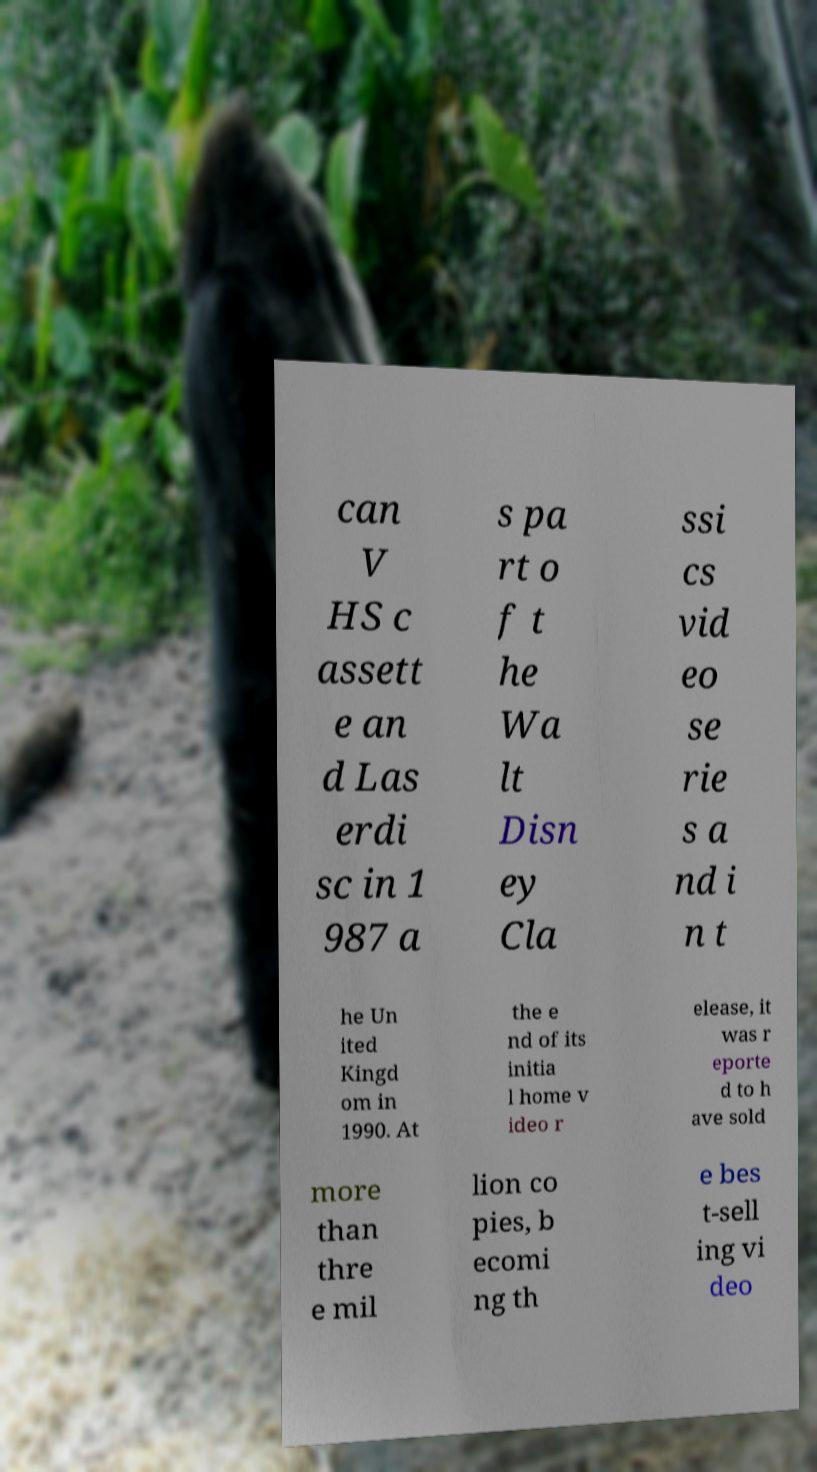Could you assist in decoding the text presented in this image and type it out clearly? can V HS c assett e an d Las erdi sc in 1 987 a s pa rt o f t he Wa lt Disn ey Cla ssi cs vid eo se rie s a nd i n t he Un ited Kingd om in 1990. At the e nd of its initia l home v ideo r elease, it was r eporte d to h ave sold more than thre e mil lion co pies, b ecomi ng th e bes t-sell ing vi deo 